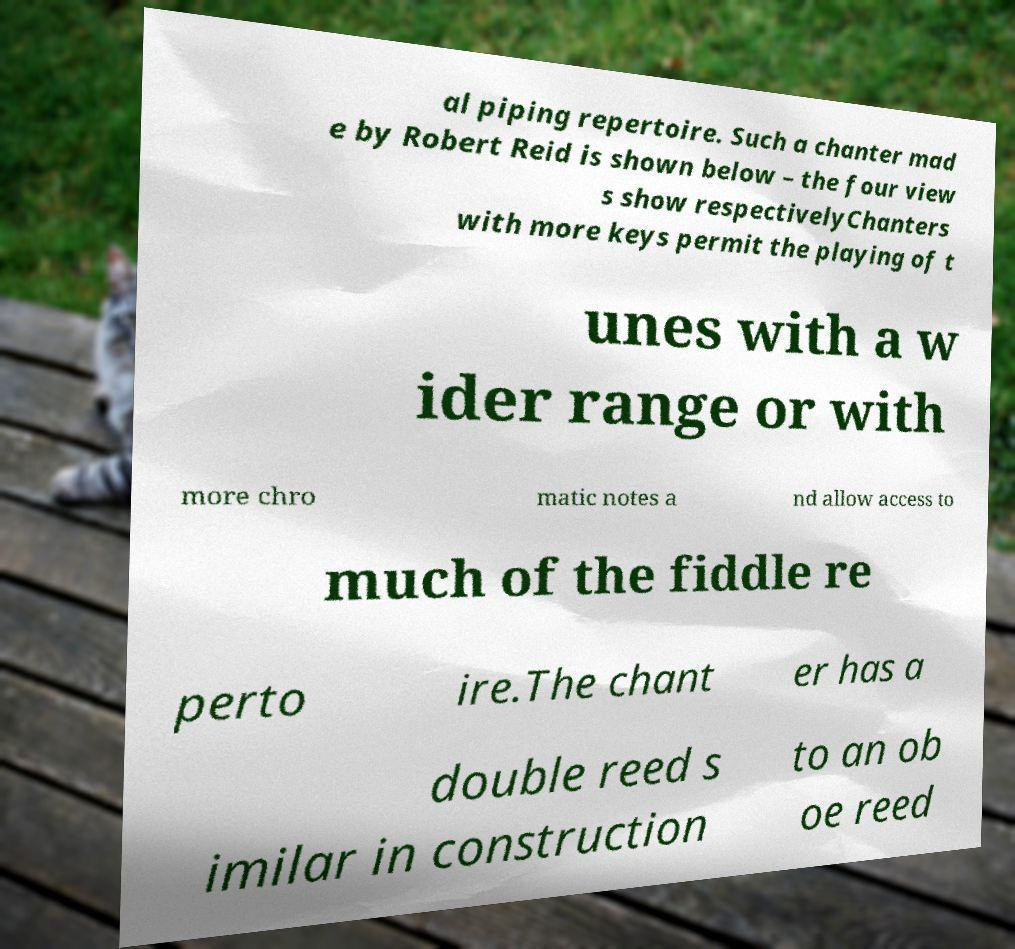Could you extract and type out the text from this image? al piping repertoire. Such a chanter mad e by Robert Reid is shown below – the four view s show respectivelyChanters with more keys permit the playing of t unes with a w ider range or with more chro matic notes a nd allow access to much of the fiddle re perto ire.The chant er has a double reed s imilar in construction to an ob oe reed 